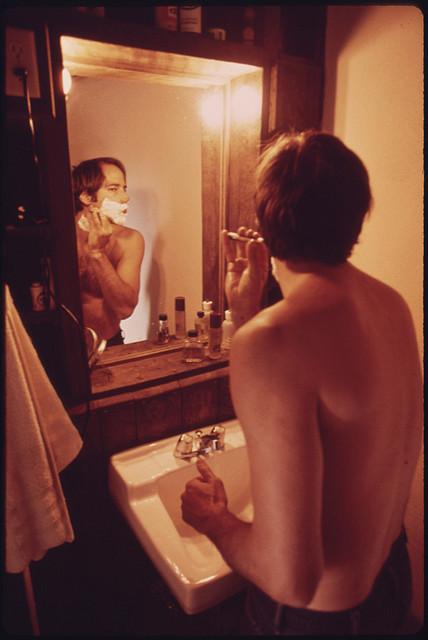Is this man brushing his teeth?
Answer briefly. No. Which hand holds the shaving blade?
Give a very brief answer. Right. What is the man doing?
Keep it brief. Shaving. 